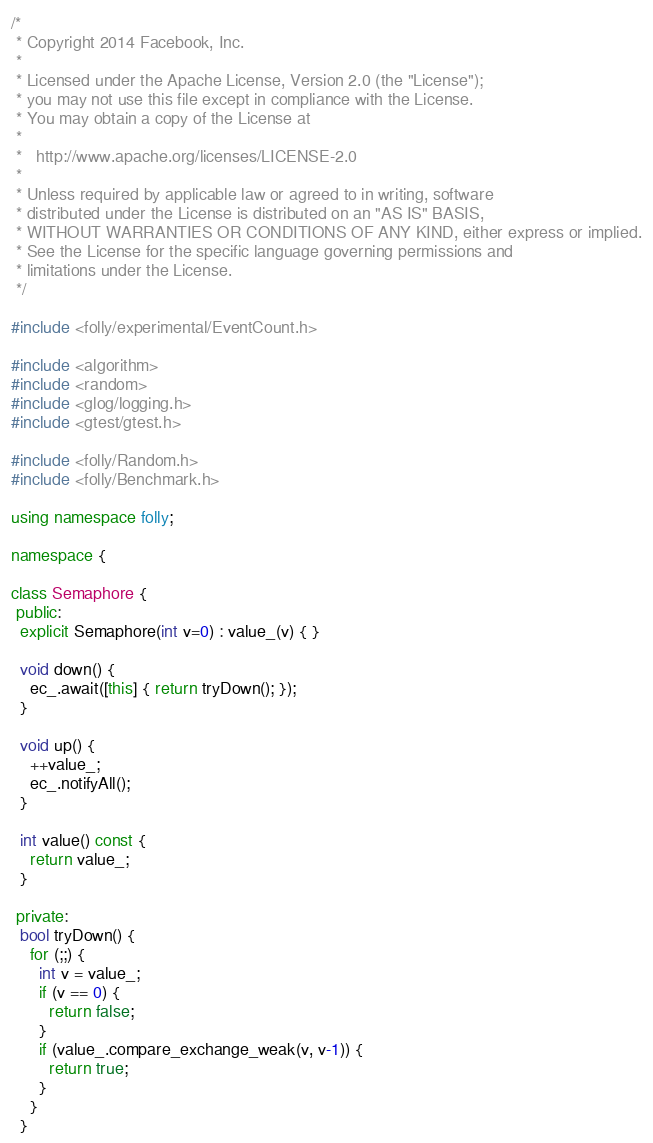Convert code to text. <code><loc_0><loc_0><loc_500><loc_500><_C++_>/*
 * Copyright 2014 Facebook, Inc.
 *
 * Licensed under the Apache License, Version 2.0 (the "License");
 * you may not use this file except in compliance with the License.
 * You may obtain a copy of the License at
 *
 *   http://www.apache.org/licenses/LICENSE-2.0
 *
 * Unless required by applicable law or agreed to in writing, software
 * distributed under the License is distributed on an "AS IS" BASIS,
 * WITHOUT WARRANTIES OR CONDITIONS OF ANY KIND, either express or implied.
 * See the License for the specific language governing permissions and
 * limitations under the License.
 */

#include <folly/experimental/EventCount.h>

#include <algorithm>
#include <random>
#include <glog/logging.h>
#include <gtest/gtest.h>

#include <folly/Random.h>
#include <folly/Benchmark.h>

using namespace folly;

namespace {

class Semaphore {
 public:
  explicit Semaphore(int v=0) : value_(v) { }

  void down() {
    ec_.await([this] { return tryDown(); });
  }

  void up() {
    ++value_;
    ec_.notifyAll();
  }

  int value() const {
    return value_;
  }

 private:
  bool tryDown() {
    for (;;) {
      int v = value_;
      if (v == 0) {
        return false;
      }
      if (value_.compare_exchange_weak(v, v-1)) {
        return true;
      }
    }
  }
</code> 